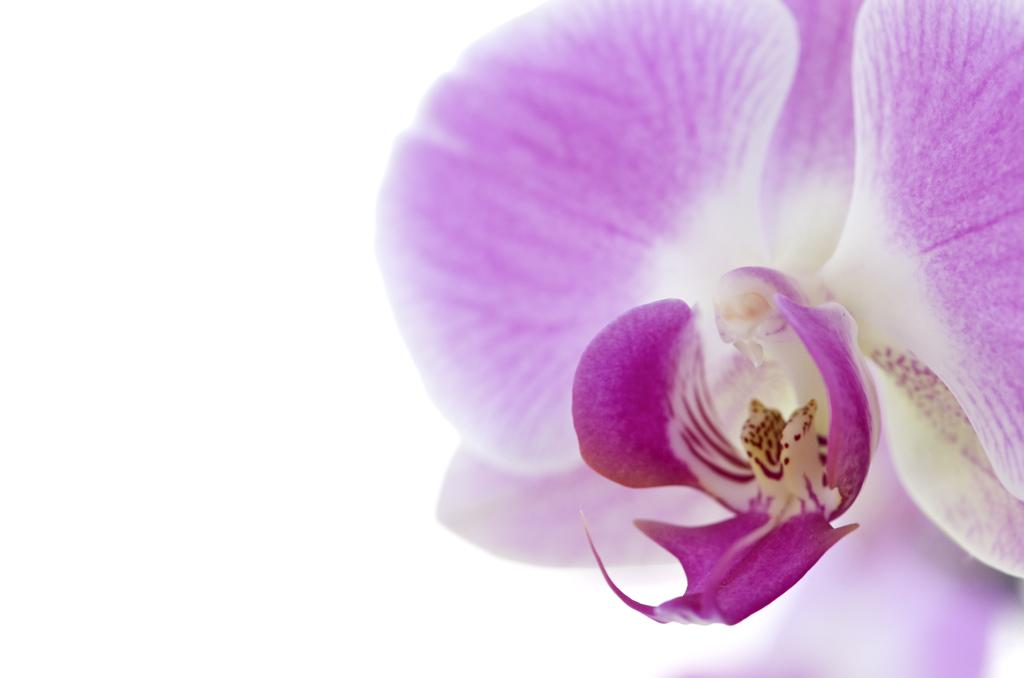What is the main subject of the image? There is a flower in the image. What color is the background of the image? The background of the image is white. How many cherries are on the sand in the image? There is no sand or cherries present in the image; it features a flower with a white background. 